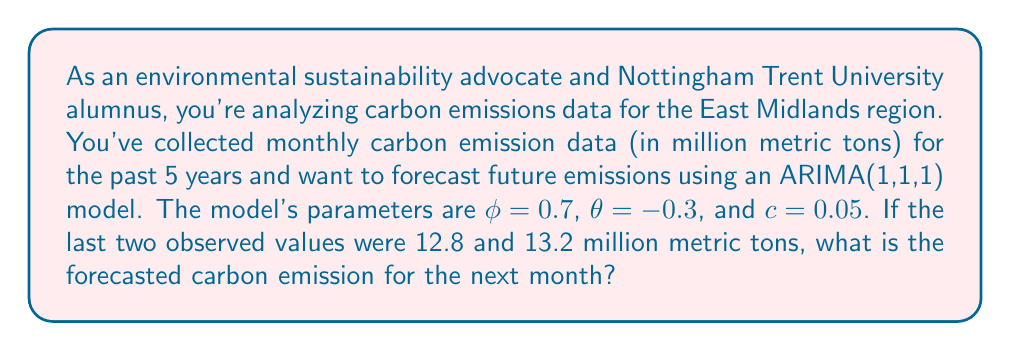Show me your answer to this math problem. To forecast future carbon emissions using an ARIMA(1,1,1) model, we need to follow these steps:

1. Recall the ARIMA(1,1,1) model equation:
   $$(1 - \phi B)(1 - B)y_t = c + (1 + \theta B)\epsilon_t$$

2. Expand the equation:
   $$y_t - (1 + \phi)y_{t-1} + \phi y_{t-2} = c + \epsilon_t + \theta \epsilon_{t-1}$$

3. Rearrange to isolate $y_t$:
   $$y_t = c + (1 + \phi)y_{t-1} - \phi y_{t-2} + \epsilon_t + \theta \epsilon_{t-1}$$

4. For forecasting, we set future error terms to their expected value of 0:
   $$\hat{y}_{t+1} = c + (1 + \phi)y_t - \phi y_{t-1}$$

5. Substitute the given values:
   $\phi = 0.7$, $\theta = -0.3$ (not used in this calculation), $c = 0.05$
   $y_t = 13.2$, $y_{t-1} = 12.8$

6. Calculate the forecast:
   $$\begin{align}
   \hat{y}_{t+1} &= 0.05 + (1 + 0.7) \times 13.2 - 0.7 \times 12.8 \\
   &= 0.05 + 1.7 \times 13.2 - 0.7 \times 12.8 \\
   &= 0.05 + 22.44 - 8.96 \\
   &= 13.53
   \end{align}$$

Therefore, the forecasted carbon emission for the next month is 13.53 million metric tons.
Answer: 13.53 million metric tons 